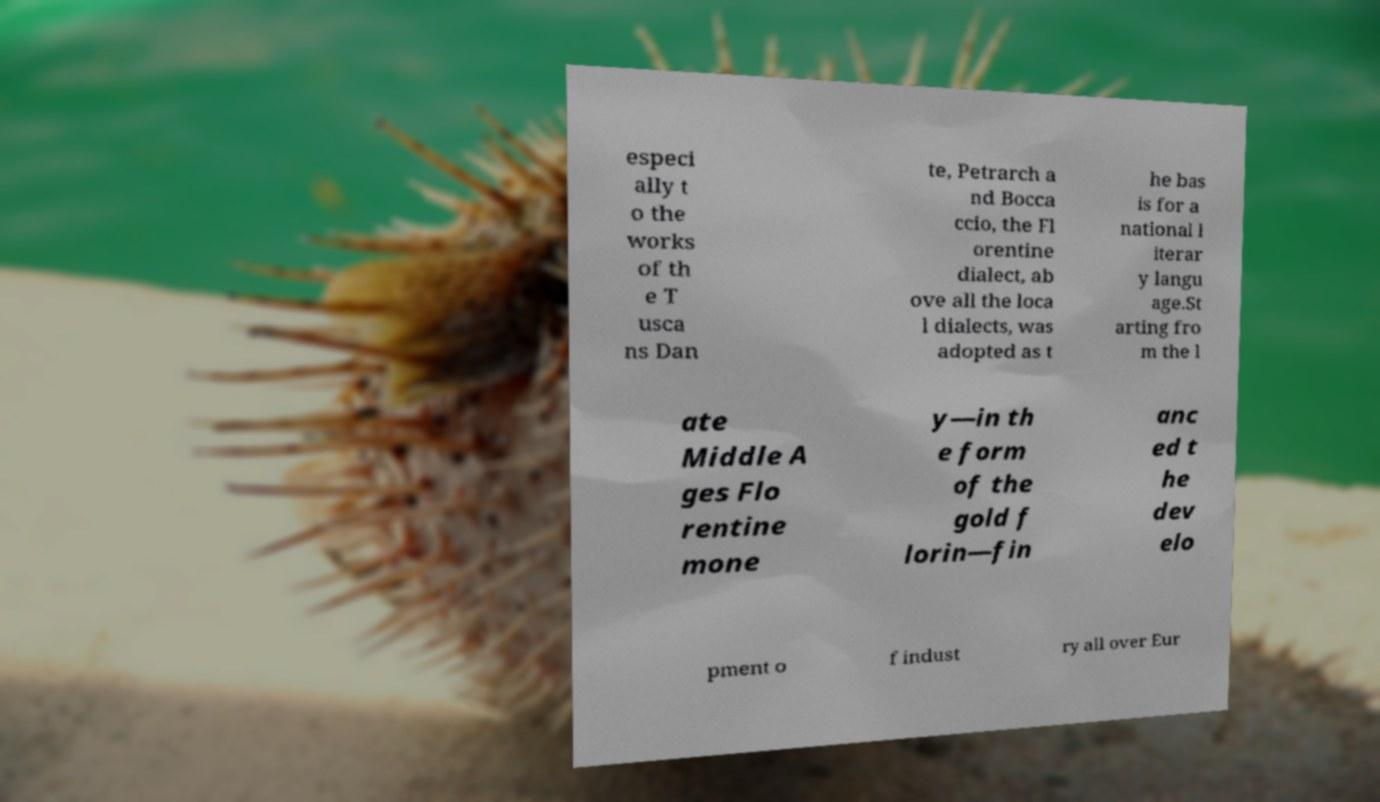Could you extract and type out the text from this image? especi ally t o the works of th e T usca ns Dan te, Petrarch a nd Bocca ccio, the Fl orentine dialect, ab ove all the loca l dialects, was adopted as t he bas is for a national l iterar y langu age.St arting fro m the l ate Middle A ges Flo rentine mone y—in th e form of the gold f lorin—fin anc ed t he dev elo pment o f indust ry all over Eur 